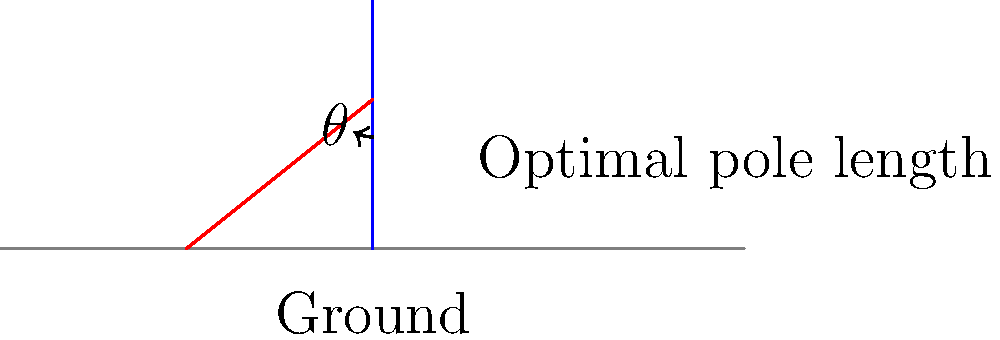As a solo hiker, you're considering the optimal trekking pole setup to reduce joint stress during your adventures. Given that the angle between the trekking pole and the ground is represented by $\theta$, what is the recommended range for $\theta$ to minimize joint stress, and how does this relate to the optimal pole length? To determine the optimal trekking pole setup for reducing joint stress, we need to consider both the pole angle and length:

1. Pole angle ($\theta$):
   - The recommended range for $\theta$ is typically between 55° and 70°.
   - This range provides an optimal balance between stability and force distribution.

2. Relationship to pole length:
   - The optimal pole length is directly related to the angle $\theta$.
   - When your arm is at a 90° angle (elbow bend), the pole should touch the ground at the recommended angle.

3. Calculating optimal pole length:
   - Let $h$ be your height in centimeters.
   - The formula for optimal pole length $(L)$ is approximately:
     $$ L = h \times \cos(\theta) $$

4. Example calculation:
   - For a hiker who is 170 cm tall, using a 60° angle:
     $$ L = 170 \times \cos(60°) \approx 85 \text{ cm} $$

5. Benefits of optimal setup:
   - Reduces stress on knees, hips, and ankles
   - Improves balance and stability
   - Enhances power and efficiency during uphill climbs

6. Adjusting for terrain:
   - Shorter poles (larger $\theta$) for uphill
   - Longer poles (smaller $\theta$) for downhill

By maintaining a pole angle between 55° and 70° and adjusting the length accordingly, you can significantly reduce joint stress during your solo hiking adventures.
Answer: 55° to 70°; pole length ≈ height × cos(angle) 